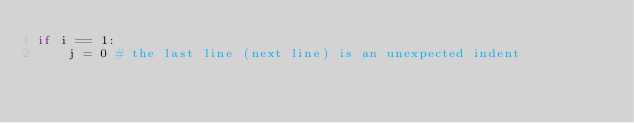<code> <loc_0><loc_0><loc_500><loc_500><_Python_>if i == 1:
    j = 0 # the last line (next line) is an unexpected indent
      </code> 